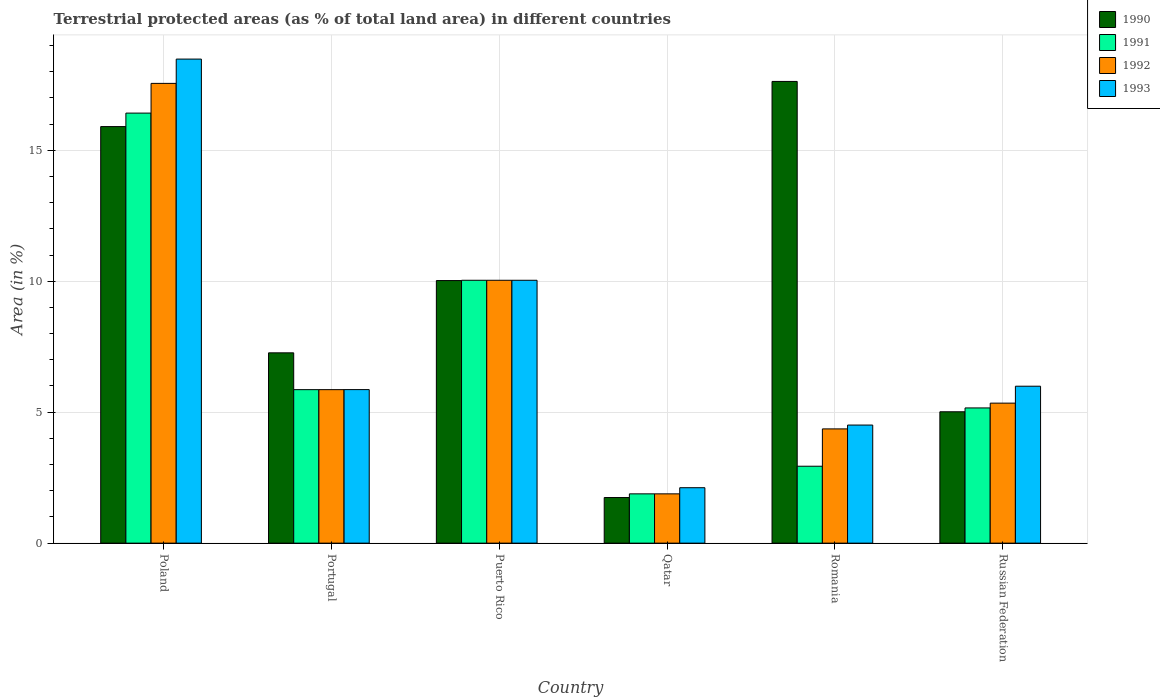How many bars are there on the 1st tick from the left?
Provide a succinct answer. 4. What is the label of the 3rd group of bars from the left?
Make the answer very short. Puerto Rico. In how many cases, is the number of bars for a given country not equal to the number of legend labels?
Offer a very short reply. 0. What is the percentage of terrestrial protected land in 1993 in Portugal?
Provide a short and direct response. 5.86. Across all countries, what is the maximum percentage of terrestrial protected land in 1993?
Your answer should be compact. 18.48. Across all countries, what is the minimum percentage of terrestrial protected land in 1991?
Your answer should be compact. 1.88. In which country was the percentage of terrestrial protected land in 1991 minimum?
Your answer should be very brief. Qatar. What is the total percentage of terrestrial protected land in 1992 in the graph?
Your response must be concise. 45.04. What is the difference between the percentage of terrestrial protected land in 1990 in Poland and that in Romania?
Your answer should be very brief. -1.72. What is the difference between the percentage of terrestrial protected land in 1991 in Portugal and the percentage of terrestrial protected land in 1992 in Russian Federation?
Offer a terse response. 0.52. What is the average percentage of terrestrial protected land in 1990 per country?
Your answer should be compact. 9.6. What is the ratio of the percentage of terrestrial protected land in 1993 in Qatar to that in Romania?
Offer a terse response. 0.47. What is the difference between the highest and the second highest percentage of terrestrial protected land in 1990?
Offer a very short reply. 7.6. What is the difference between the highest and the lowest percentage of terrestrial protected land in 1990?
Make the answer very short. 15.89. In how many countries, is the percentage of terrestrial protected land in 1991 greater than the average percentage of terrestrial protected land in 1991 taken over all countries?
Provide a short and direct response. 2. Is it the case that in every country, the sum of the percentage of terrestrial protected land in 1991 and percentage of terrestrial protected land in 1992 is greater than the sum of percentage of terrestrial protected land in 1990 and percentage of terrestrial protected land in 1993?
Provide a short and direct response. No. What does the 4th bar from the left in Puerto Rico represents?
Provide a succinct answer. 1993. Is it the case that in every country, the sum of the percentage of terrestrial protected land in 1993 and percentage of terrestrial protected land in 1991 is greater than the percentage of terrestrial protected land in 1992?
Give a very brief answer. Yes. Are all the bars in the graph horizontal?
Your response must be concise. No. How many countries are there in the graph?
Provide a short and direct response. 6. What is the difference between two consecutive major ticks on the Y-axis?
Offer a very short reply. 5. Where does the legend appear in the graph?
Give a very brief answer. Top right. What is the title of the graph?
Offer a very short reply. Terrestrial protected areas (as % of total land area) in different countries. What is the label or title of the Y-axis?
Your answer should be very brief. Area (in %). What is the Area (in %) of 1990 in Poland?
Keep it short and to the point. 15.9. What is the Area (in %) in 1991 in Poland?
Ensure brevity in your answer.  16.42. What is the Area (in %) in 1992 in Poland?
Your answer should be very brief. 17.55. What is the Area (in %) in 1993 in Poland?
Keep it short and to the point. 18.48. What is the Area (in %) of 1990 in Portugal?
Give a very brief answer. 7.27. What is the Area (in %) in 1991 in Portugal?
Offer a terse response. 5.86. What is the Area (in %) of 1992 in Portugal?
Ensure brevity in your answer.  5.86. What is the Area (in %) in 1993 in Portugal?
Provide a succinct answer. 5.86. What is the Area (in %) in 1990 in Puerto Rico?
Give a very brief answer. 10.03. What is the Area (in %) in 1991 in Puerto Rico?
Your answer should be compact. 10.04. What is the Area (in %) in 1992 in Puerto Rico?
Offer a terse response. 10.04. What is the Area (in %) of 1993 in Puerto Rico?
Provide a succinct answer. 10.04. What is the Area (in %) in 1990 in Qatar?
Provide a short and direct response. 1.74. What is the Area (in %) of 1991 in Qatar?
Provide a succinct answer. 1.88. What is the Area (in %) in 1992 in Qatar?
Ensure brevity in your answer.  1.88. What is the Area (in %) in 1993 in Qatar?
Your response must be concise. 2.12. What is the Area (in %) in 1990 in Romania?
Your response must be concise. 17.63. What is the Area (in %) of 1991 in Romania?
Offer a very short reply. 2.94. What is the Area (in %) of 1992 in Romania?
Give a very brief answer. 4.36. What is the Area (in %) of 1993 in Romania?
Ensure brevity in your answer.  4.51. What is the Area (in %) in 1990 in Russian Federation?
Offer a very short reply. 5.02. What is the Area (in %) of 1991 in Russian Federation?
Your answer should be very brief. 5.16. What is the Area (in %) of 1992 in Russian Federation?
Your answer should be very brief. 5.35. What is the Area (in %) of 1993 in Russian Federation?
Keep it short and to the point. 5.99. Across all countries, what is the maximum Area (in %) in 1990?
Your response must be concise. 17.63. Across all countries, what is the maximum Area (in %) of 1991?
Your answer should be compact. 16.42. Across all countries, what is the maximum Area (in %) in 1992?
Your answer should be very brief. 17.55. Across all countries, what is the maximum Area (in %) in 1993?
Offer a terse response. 18.48. Across all countries, what is the minimum Area (in %) of 1990?
Give a very brief answer. 1.74. Across all countries, what is the minimum Area (in %) in 1991?
Offer a very short reply. 1.88. Across all countries, what is the minimum Area (in %) of 1992?
Offer a very short reply. 1.88. Across all countries, what is the minimum Area (in %) in 1993?
Offer a terse response. 2.12. What is the total Area (in %) in 1990 in the graph?
Your answer should be very brief. 57.58. What is the total Area (in %) in 1991 in the graph?
Give a very brief answer. 42.3. What is the total Area (in %) of 1992 in the graph?
Your response must be concise. 45.04. What is the total Area (in %) in 1993 in the graph?
Offer a very short reply. 47. What is the difference between the Area (in %) in 1990 in Poland and that in Portugal?
Offer a very short reply. 8.64. What is the difference between the Area (in %) in 1991 in Poland and that in Portugal?
Your answer should be compact. 10.56. What is the difference between the Area (in %) in 1992 in Poland and that in Portugal?
Ensure brevity in your answer.  11.69. What is the difference between the Area (in %) of 1993 in Poland and that in Portugal?
Offer a very short reply. 12.62. What is the difference between the Area (in %) of 1990 in Poland and that in Puerto Rico?
Offer a terse response. 5.88. What is the difference between the Area (in %) of 1991 in Poland and that in Puerto Rico?
Provide a succinct answer. 6.38. What is the difference between the Area (in %) in 1992 in Poland and that in Puerto Rico?
Ensure brevity in your answer.  7.52. What is the difference between the Area (in %) in 1993 in Poland and that in Puerto Rico?
Your answer should be very brief. 8.45. What is the difference between the Area (in %) in 1990 in Poland and that in Qatar?
Offer a terse response. 14.16. What is the difference between the Area (in %) of 1991 in Poland and that in Qatar?
Ensure brevity in your answer.  14.54. What is the difference between the Area (in %) of 1992 in Poland and that in Qatar?
Provide a succinct answer. 15.67. What is the difference between the Area (in %) of 1993 in Poland and that in Qatar?
Your answer should be very brief. 16.37. What is the difference between the Area (in %) of 1990 in Poland and that in Romania?
Your response must be concise. -1.72. What is the difference between the Area (in %) of 1991 in Poland and that in Romania?
Provide a succinct answer. 13.48. What is the difference between the Area (in %) in 1992 in Poland and that in Romania?
Offer a terse response. 13.19. What is the difference between the Area (in %) of 1993 in Poland and that in Romania?
Keep it short and to the point. 13.97. What is the difference between the Area (in %) of 1990 in Poland and that in Russian Federation?
Provide a short and direct response. 10.89. What is the difference between the Area (in %) in 1991 in Poland and that in Russian Federation?
Offer a very short reply. 11.26. What is the difference between the Area (in %) in 1992 in Poland and that in Russian Federation?
Provide a succinct answer. 12.21. What is the difference between the Area (in %) of 1993 in Poland and that in Russian Federation?
Provide a succinct answer. 12.49. What is the difference between the Area (in %) in 1990 in Portugal and that in Puerto Rico?
Keep it short and to the point. -2.76. What is the difference between the Area (in %) in 1991 in Portugal and that in Puerto Rico?
Offer a terse response. -4.18. What is the difference between the Area (in %) in 1992 in Portugal and that in Puerto Rico?
Make the answer very short. -4.18. What is the difference between the Area (in %) in 1993 in Portugal and that in Puerto Rico?
Your answer should be compact. -4.17. What is the difference between the Area (in %) in 1990 in Portugal and that in Qatar?
Offer a very short reply. 5.53. What is the difference between the Area (in %) in 1991 in Portugal and that in Qatar?
Give a very brief answer. 3.98. What is the difference between the Area (in %) in 1992 in Portugal and that in Qatar?
Your answer should be compact. 3.98. What is the difference between the Area (in %) in 1993 in Portugal and that in Qatar?
Provide a succinct answer. 3.75. What is the difference between the Area (in %) of 1990 in Portugal and that in Romania?
Offer a terse response. -10.36. What is the difference between the Area (in %) of 1991 in Portugal and that in Romania?
Make the answer very short. 2.92. What is the difference between the Area (in %) of 1992 in Portugal and that in Romania?
Provide a short and direct response. 1.5. What is the difference between the Area (in %) of 1993 in Portugal and that in Romania?
Keep it short and to the point. 1.35. What is the difference between the Area (in %) in 1990 in Portugal and that in Russian Federation?
Provide a succinct answer. 2.25. What is the difference between the Area (in %) in 1991 in Portugal and that in Russian Federation?
Offer a very short reply. 0.7. What is the difference between the Area (in %) of 1992 in Portugal and that in Russian Federation?
Your answer should be very brief. 0.52. What is the difference between the Area (in %) in 1993 in Portugal and that in Russian Federation?
Offer a terse response. -0.13. What is the difference between the Area (in %) of 1990 in Puerto Rico and that in Qatar?
Your response must be concise. 8.28. What is the difference between the Area (in %) in 1991 in Puerto Rico and that in Qatar?
Your response must be concise. 8.15. What is the difference between the Area (in %) in 1992 in Puerto Rico and that in Qatar?
Give a very brief answer. 8.15. What is the difference between the Area (in %) in 1993 in Puerto Rico and that in Qatar?
Your answer should be very brief. 7.92. What is the difference between the Area (in %) of 1990 in Puerto Rico and that in Romania?
Provide a succinct answer. -7.6. What is the difference between the Area (in %) in 1991 in Puerto Rico and that in Romania?
Keep it short and to the point. 7.1. What is the difference between the Area (in %) of 1992 in Puerto Rico and that in Romania?
Provide a short and direct response. 5.67. What is the difference between the Area (in %) of 1993 in Puerto Rico and that in Romania?
Your response must be concise. 5.53. What is the difference between the Area (in %) of 1990 in Puerto Rico and that in Russian Federation?
Your response must be concise. 5.01. What is the difference between the Area (in %) in 1991 in Puerto Rico and that in Russian Federation?
Keep it short and to the point. 4.87. What is the difference between the Area (in %) in 1992 in Puerto Rico and that in Russian Federation?
Your answer should be compact. 4.69. What is the difference between the Area (in %) in 1993 in Puerto Rico and that in Russian Federation?
Offer a very short reply. 4.04. What is the difference between the Area (in %) in 1990 in Qatar and that in Romania?
Provide a succinct answer. -15.89. What is the difference between the Area (in %) of 1991 in Qatar and that in Romania?
Keep it short and to the point. -1.05. What is the difference between the Area (in %) of 1992 in Qatar and that in Romania?
Give a very brief answer. -2.48. What is the difference between the Area (in %) in 1993 in Qatar and that in Romania?
Provide a short and direct response. -2.39. What is the difference between the Area (in %) in 1990 in Qatar and that in Russian Federation?
Your answer should be very brief. -3.27. What is the difference between the Area (in %) in 1991 in Qatar and that in Russian Federation?
Your answer should be compact. -3.28. What is the difference between the Area (in %) of 1992 in Qatar and that in Russian Federation?
Keep it short and to the point. -3.46. What is the difference between the Area (in %) in 1993 in Qatar and that in Russian Federation?
Ensure brevity in your answer.  -3.88. What is the difference between the Area (in %) in 1990 in Romania and that in Russian Federation?
Give a very brief answer. 12.61. What is the difference between the Area (in %) of 1991 in Romania and that in Russian Federation?
Ensure brevity in your answer.  -2.23. What is the difference between the Area (in %) of 1992 in Romania and that in Russian Federation?
Your answer should be compact. -0.98. What is the difference between the Area (in %) in 1993 in Romania and that in Russian Federation?
Your answer should be compact. -1.48. What is the difference between the Area (in %) in 1990 in Poland and the Area (in %) in 1991 in Portugal?
Provide a short and direct response. 10.04. What is the difference between the Area (in %) in 1990 in Poland and the Area (in %) in 1992 in Portugal?
Provide a succinct answer. 10.04. What is the difference between the Area (in %) of 1990 in Poland and the Area (in %) of 1993 in Portugal?
Your answer should be compact. 10.04. What is the difference between the Area (in %) in 1991 in Poland and the Area (in %) in 1992 in Portugal?
Provide a succinct answer. 10.56. What is the difference between the Area (in %) of 1991 in Poland and the Area (in %) of 1993 in Portugal?
Your answer should be very brief. 10.56. What is the difference between the Area (in %) in 1992 in Poland and the Area (in %) in 1993 in Portugal?
Offer a terse response. 11.69. What is the difference between the Area (in %) in 1990 in Poland and the Area (in %) in 1991 in Puerto Rico?
Keep it short and to the point. 5.87. What is the difference between the Area (in %) of 1990 in Poland and the Area (in %) of 1992 in Puerto Rico?
Offer a very short reply. 5.87. What is the difference between the Area (in %) in 1990 in Poland and the Area (in %) in 1993 in Puerto Rico?
Your answer should be very brief. 5.87. What is the difference between the Area (in %) of 1991 in Poland and the Area (in %) of 1992 in Puerto Rico?
Provide a short and direct response. 6.38. What is the difference between the Area (in %) of 1991 in Poland and the Area (in %) of 1993 in Puerto Rico?
Offer a very short reply. 6.38. What is the difference between the Area (in %) in 1992 in Poland and the Area (in %) in 1993 in Puerto Rico?
Ensure brevity in your answer.  7.52. What is the difference between the Area (in %) of 1990 in Poland and the Area (in %) of 1991 in Qatar?
Provide a succinct answer. 14.02. What is the difference between the Area (in %) in 1990 in Poland and the Area (in %) in 1992 in Qatar?
Your answer should be very brief. 14.02. What is the difference between the Area (in %) in 1990 in Poland and the Area (in %) in 1993 in Qatar?
Give a very brief answer. 13.79. What is the difference between the Area (in %) in 1991 in Poland and the Area (in %) in 1992 in Qatar?
Offer a terse response. 14.54. What is the difference between the Area (in %) of 1991 in Poland and the Area (in %) of 1993 in Qatar?
Provide a short and direct response. 14.3. What is the difference between the Area (in %) in 1992 in Poland and the Area (in %) in 1993 in Qatar?
Your response must be concise. 15.44. What is the difference between the Area (in %) in 1990 in Poland and the Area (in %) in 1991 in Romania?
Your answer should be very brief. 12.97. What is the difference between the Area (in %) of 1990 in Poland and the Area (in %) of 1992 in Romania?
Make the answer very short. 11.54. What is the difference between the Area (in %) of 1990 in Poland and the Area (in %) of 1993 in Romania?
Provide a short and direct response. 11.4. What is the difference between the Area (in %) of 1991 in Poland and the Area (in %) of 1992 in Romania?
Your answer should be compact. 12.06. What is the difference between the Area (in %) of 1991 in Poland and the Area (in %) of 1993 in Romania?
Your response must be concise. 11.91. What is the difference between the Area (in %) of 1992 in Poland and the Area (in %) of 1993 in Romania?
Make the answer very short. 13.04. What is the difference between the Area (in %) in 1990 in Poland and the Area (in %) in 1991 in Russian Federation?
Offer a terse response. 10.74. What is the difference between the Area (in %) in 1990 in Poland and the Area (in %) in 1992 in Russian Federation?
Your response must be concise. 10.56. What is the difference between the Area (in %) of 1990 in Poland and the Area (in %) of 1993 in Russian Federation?
Offer a very short reply. 9.91. What is the difference between the Area (in %) in 1991 in Poland and the Area (in %) in 1992 in Russian Federation?
Your response must be concise. 11.07. What is the difference between the Area (in %) in 1991 in Poland and the Area (in %) in 1993 in Russian Federation?
Provide a succinct answer. 10.43. What is the difference between the Area (in %) in 1992 in Poland and the Area (in %) in 1993 in Russian Federation?
Ensure brevity in your answer.  11.56. What is the difference between the Area (in %) of 1990 in Portugal and the Area (in %) of 1991 in Puerto Rico?
Keep it short and to the point. -2.77. What is the difference between the Area (in %) in 1990 in Portugal and the Area (in %) in 1992 in Puerto Rico?
Give a very brief answer. -2.77. What is the difference between the Area (in %) in 1990 in Portugal and the Area (in %) in 1993 in Puerto Rico?
Give a very brief answer. -2.77. What is the difference between the Area (in %) in 1991 in Portugal and the Area (in %) in 1992 in Puerto Rico?
Your response must be concise. -4.18. What is the difference between the Area (in %) in 1991 in Portugal and the Area (in %) in 1993 in Puerto Rico?
Your answer should be very brief. -4.18. What is the difference between the Area (in %) of 1992 in Portugal and the Area (in %) of 1993 in Puerto Rico?
Your answer should be compact. -4.18. What is the difference between the Area (in %) of 1990 in Portugal and the Area (in %) of 1991 in Qatar?
Provide a succinct answer. 5.38. What is the difference between the Area (in %) in 1990 in Portugal and the Area (in %) in 1992 in Qatar?
Give a very brief answer. 5.38. What is the difference between the Area (in %) of 1990 in Portugal and the Area (in %) of 1993 in Qatar?
Provide a succinct answer. 5.15. What is the difference between the Area (in %) in 1991 in Portugal and the Area (in %) in 1992 in Qatar?
Provide a succinct answer. 3.98. What is the difference between the Area (in %) of 1991 in Portugal and the Area (in %) of 1993 in Qatar?
Provide a succinct answer. 3.74. What is the difference between the Area (in %) in 1992 in Portugal and the Area (in %) in 1993 in Qatar?
Give a very brief answer. 3.74. What is the difference between the Area (in %) of 1990 in Portugal and the Area (in %) of 1991 in Romania?
Make the answer very short. 4.33. What is the difference between the Area (in %) in 1990 in Portugal and the Area (in %) in 1992 in Romania?
Provide a succinct answer. 2.9. What is the difference between the Area (in %) in 1990 in Portugal and the Area (in %) in 1993 in Romania?
Your answer should be compact. 2.76. What is the difference between the Area (in %) of 1991 in Portugal and the Area (in %) of 1992 in Romania?
Your response must be concise. 1.5. What is the difference between the Area (in %) of 1991 in Portugal and the Area (in %) of 1993 in Romania?
Provide a short and direct response. 1.35. What is the difference between the Area (in %) in 1992 in Portugal and the Area (in %) in 1993 in Romania?
Provide a short and direct response. 1.35. What is the difference between the Area (in %) of 1990 in Portugal and the Area (in %) of 1991 in Russian Federation?
Your answer should be compact. 2.1. What is the difference between the Area (in %) in 1990 in Portugal and the Area (in %) in 1992 in Russian Federation?
Keep it short and to the point. 1.92. What is the difference between the Area (in %) in 1990 in Portugal and the Area (in %) in 1993 in Russian Federation?
Your answer should be compact. 1.27. What is the difference between the Area (in %) of 1991 in Portugal and the Area (in %) of 1992 in Russian Federation?
Offer a terse response. 0.52. What is the difference between the Area (in %) of 1991 in Portugal and the Area (in %) of 1993 in Russian Federation?
Your answer should be very brief. -0.13. What is the difference between the Area (in %) in 1992 in Portugal and the Area (in %) in 1993 in Russian Federation?
Give a very brief answer. -0.13. What is the difference between the Area (in %) in 1990 in Puerto Rico and the Area (in %) in 1991 in Qatar?
Provide a short and direct response. 8.14. What is the difference between the Area (in %) of 1990 in Puerto Rico and the Area (in %) of 1992 in Qatar?
Your answer should be compact. 8.14. What is the difference between the Area (in %) in 1990 in Puerto Rico and the Area (in %) in 1993 in Qatar?
Keep it short and to the point. 7.91. What is the difference between the Area (in %) of 1991 in Puerto Rico and the Area (in %) of 1992 in Qatar?
Keep it short and to the point. 8.15. What is the difference between the Area (in %) of 1991 in Puerto Rico and the Area (in %) of 1993 in Qatar?
Give a very brief answer. 7.92. What is the difference between the Area (in %) of 1992 in Puerto Rico and the Area (in %) of 1993 in Qatar?
Keep it short and to the point. 7.92. What is the difference between the Area (in %) of 1990 in Puerto Rico and the Area (in %) of 1991 in Romania?
Your response must be concise. 7.09. What is the difference between the Area (in %) of 1990 in Puerto Rico and the Area (in %) of 1992 in Romania?
Your response must be concise. 5.66. What is the difference between the Area (in %) of 1990 in Puerto Rico and the Area (in %) of 1993 in Romania?
Provide a succinct answer. 5.52. What is the difference between the Area (in %) of 1991 in Puerto Rico and the Area (in %) of 1992 in Romania?
Offer a terse response. 5.67. What is the difference between the Area (in %) in 1991 in Puerto Rico and the Area (in %) in 1993 in Romania?
Give a very brief answer. 5.53. What is the difference between the Area (in %) in 1992 in Puerto Rico and the Area (in %) in 1993 in Romania?
Your response must be concise. 5.53. What is the difference between the Area (in %) in 1990 in Puerto Rico and the Area (in %) in 1991 in Russian Federation?
Give a very brief answer. 4.86. What is the difference between the Area (in %) of 1990 in Puerto Rico and the Area (in %) of 1992 in Russian Federation?
Provide a short and direct response. 4.68. What is the difference between the Area (in %) in 1990 in Puerto Rico and the Area (in %) in 1993 in Russian Federation?
Your response must be concise. 4.03. What is the difference between the Area (in %) of 1991 in Puerto Rico and the Area (in %) of 1992 in Russian Federation?
Make the answer very short. 4.69. What is the difference between the Area (in %) of 1991 in Puerto Rico and the Area (in %) of 1993 in Russian Federation?
Offer a very short reply. 4.04. What is the difference between the Area (in %) of 1992 in Puerto Rico and the Area (in %) of 1993 in Russian Federation?
Your answer should be compact. 4.04. What is the difference between the Area (in %) of 1990 in Qatar and the Area (in %) of 1991 in Romania?
Provide a succinct answer. -1.2. What is the difference between the Area (in %) of 1990 in Qatar and the Area (in %) of 1992 in Romania?
Ensure brevity in your answer.  -2.62. What is the difference between the Area (in %) of 1990 in Qatar and the Area (in %) of 1993 in Romania?
Give a very brief answer. -2.77. What is the difference between the Area (in %) of 1991 in Qatar and the Area (in %) of 1992 in Romania?
Provide a short and direct response. -2.48. What is the difference between the Area (in %) of 1991 in Qatar and the Area (in %) of 1993 in Romania?
Keep it short and to the point. -2.63. What is the difference between the Area (in %) of 1992 in Qatar and the Area (in %) of 1993 in Romania?
Make the answer very short. -2.63. What is the difference between the Area (in %) in 1990 in Qatar and the Area (in %) in 1991 in Russian Federation?
Your answer should be compact. -3.42. What is the difference between the Area (in %) of 1990 in Qatar and the Area (in %) of 1992 in Russian Federation?
Your response must be concise. -3.6. What is the difference between the Area (in %) of 1990 in Qatar and the Area (in %) of 1993 in Russian Federation?
Provide a short and direct response. -4.25. What is the difference between the Area (in %) in 1991 in Qatar and the Area (in %) in 1992 in Russian Federation?
Your answer should be compact. -3.46. What is the difference between the Area (in %) in 1991 in Qatar and the Area (in %) in 1993 in Russian Federation?
Your response must be concise. -4.11. What is the difference between the Area (in %) of 1992 in Qatar and the Area (in %) of 1993 in Russian Federation?
Your response must be concise. -4.11. What is the difference between the Area (in %) in 1990 in Romania and the Area (in %) in 1991 in Russian Federation?
Make the answer very short. 12.47. What is the difference between the Area (in %) of 1990 in Romania and the Area (in %) of 1992 in Russian Federation?
Your answer should be compact. 12.28. What is the difference between the Area (in %) in 1990 in Romania and the Area (in %) in 1993 in Russian Federation?
Give a very brief answer. 11.64. What is the difference between the Area (in %) in 1991 in Romania and the Area (in %) in 1992 in Russian Federation?
Your answer should be compact. -2.41. What is the difference between the Area (in %) of 1991 in Romania and the Area (in %) of 1993 in Russian Federation?
Offer a terse response. -3.06. What is the difference between the Area (in %) of 1992 in Romania and the Area (in %) of 1993 in Russian Federation?
Keep it short and to the point. -1.63. What is the average Area (in %) of 1990 per country?
Provide a succinct answer. 9.6. What is the average Area (in %) in 1991 per country?
Your answer should be compact. 7.05. What is the average Area (in %) in 1992 per country?
Your answer should be compact. 7.51. What is the average Area (in %) of 1993 per country?
Your answer should be very brief. 7.83. What is the difference between the Area (in %) in 1990 and Area (in %) in 1991 in Poland?
Provide a succinct answer. -0.51. What is the difference between the Area (in %) in 1990 and Area (in %) in 1992 in Poland?
Your answer should be very brief. -1.65. What is the difference between the Area (in %) in 1990 and Area (in %) in 1993 in Poland?
Your answer should be compact. -2.58. What is the difference between the Area (in %) in 1991 and Area (in %) in 1992 in Poland?
Offer a very short reply. -1.13. What is the difference between the Area (in %) in 1991 and Area (in %) in 1993 in Poland?
Ensure brevity in your answer.  -2.06. What is the difference between the Area (in %) of 1992 and Area (in %) of 1993 in Poland?
Give a very brief answer. -0.93. What is the difference between the Area (in %) of 1990 and Area (in %) of 1991 in Portugal?
Offer a terse response. 1.41. What is the difference between the Area (in %) of 1990 and Area (in %) of 1992 in Portugal?
Ensure brevity in your answer.  1.41. What is the difference between the Area (in %) in 1990 and Area (in %) in 1993 in Portugal?
Keep it short and to the point. 1.4. What is the difference between the Area (in %) in 1991 and Area (in %) in 1992 in Portugal?
Your response must be concise. 0. What is the difference between the Area (in %) in 1991 and Area (in %) in 1993 in Portugal?
Make the answer very short. -0. What is the difference between the Area (in %) of 1992 and Area (in %) of 1993 in Portugal?
Your response must be concise. -0. What is the difference between the Area (in %) in 1990 and Area (in %) in 1991 in Puerto Rico?
Provide a succinct answer. -0.01. What is the difference between the Area (in %) in 1990 and Area (in %) in 1992 in Puerto Rico?
Give a very brief answer. -0.01. What is the difference between the Area (in %) in 1990 and Area (in %) in 1993 in Puerto Rico?
Provide a short and direct response. -0.01. What is the difference between the Area (in %) of 1991 and Area (in %) of 1993 in Puerto Rico?
Provide a succinct answer. 0. What is the difference between the Area (in %) of 1990 and Area (in %) of 1991 in Qatar?
Provide a succinct answer. -0.14. What is the difference between the Area (in %) in 1990 and Area (in %) in 1992 in Qatar?
Your answer should be very brief. -0.14. What is the difference between the Area (in %) in 1990 and Area (in %) in 1993 in Qatar?
Provide a short and direct response. -0.38. What is the difference between the Area (in %) of 1991 and Area (in %) of 1993 in Qatar?
Provide a short and direct response. -0.23. What is the difference between the Area (in %) in 1992 and Area (in %) in 1993 in Qatar?
Keep it short and to the point. -0.23. What is the difference between the Area (in %) of 1990 and Area (in %) of 1991 in Romania?
Provide a succinct answer. 14.69. What is the difference between the Area (in %) of 1990 and Area (in %) of 1992 in Romania?
Give a very brief answer. 13.27. What is the difference between the Area (in %) of 1990 and Area (in %) of 1993 in Romania?
Ensure brevity in your answer.  13.12. What is the difference between the Area (in %) of 1991 and Area (in %) of 1992 in Romania?
Make the answer very short. -1.43. What is the difference between the Area (in %) in 1991 and Area (in %) in 1993 in Romania?
Provide a succinct answer. -1.57. What is the difference between the Area (in %) in 1992 and Area (in %) in 1993 in Romania?
Your answer should be very brief. -0.15. What is the difference between the Area (in %) of 1990 and Area (in %) of 1991 in Russian Federation?
Your answer should be compact. -0.15. What is the difference between the Area (in %) in 1990 and Area (in %) in 1992 in Russian Federation?
Your response must be concise. -0.33. What is the difference between the Area (in %) in 1990 and Area (in %) in 1993 in Russian Federation?
Provide a short and direct response. -0.98. What is the difference between the Area (in %) in 1991 and Area (in %) in 1992 in Russian Federation?
Keep it short and to the point. -0.18. What is the difference between the Area (in %) in 1991 and Area (in %) in 1993 in Russian Federation?
Your answer should be very brief. -0.83. What is the difference between the Area (in %) of 1992 and Area (in %) of 1993 in Russian Federation?
Your response must be concise. -0.65. What is the ratio of the Area (in %) in 1990 in Poland to that in Portugal?
Keep it short and to the point. 2.19. What is the ratio of the Area (in %) in 1991 in Poland to that in Portugal?
Your answer should be compact. 2.8. What is the ratio of the Area (in %) of 1992 in Poland to that in Portugal?
Your answer should be very brief. 3. What is the ratio of the Area (in %) in 1993 in Poland to that in Portugal?
Ensure brevity in your answer.  3.15. What is the ratio of the Area (in %) in 1990 in Poland to that in Puerto Rico?
Make the answer very short. 1.59. What is the ratio of the Area (in %) in 1991 in Poland to that in Puerto Rico?
Provide a succinct answer. 1.64. What is the ratio of the Area (in %) in 1992 in Poland to that in Puerto Rico?
Provide a succinct answer. 1.75. What is the ratio of the Area (in %) of 1993 in Poland to that in Puerto Rico?
Keep it short and to the point. 1.84. What is the ratio of the Area (in %) in 1990 in Poland to that in Qatar?
Your response must be concise. 9.13. What is the ratio of the Area (in %) in 1991 in Poland to that in Qatar?
Ensure brevity in your answer.  8.72. What is the ratio of the Area (in %) of 1992 in Poland to that in Qatar?
Offer a very short reply. 9.33. What is the ratio of the Area (in %) of 1993 in Poland to that in Qatar?
Offer a very short reply. 8.73. What is the ratio of the Area (in %) of 1990 in Poland to that in Romania?
Your response must be concise. 0.9. What is the ratio of the Area (in %) of 1991 in Poland to that in Romania?
Your answer should be compact. 5.59. What is the ratio of the Area (in %) of 1992 in Poland to that in Romania?
Provide a short and direct response. 4.02. What is the ratio of the Area (in %) in 1993 in Poland to that in Romania?
Provide a succinct answer. 4.1. What is the ratio of the Area (in %) of 1990 in Poland to that in Russian Federation?
Make the answer very short. 3.17. What is the ratio of the Area (in %) of 1991 in Poland to that in Russian Federation?
Give a very brief answer. 3.18. What is the ratio of the Area (in %) of 1992 in Poland to that in Russian Federation?
Ensure brevity in your answer.  3.28. What is the ratio of the Area (in %) in 1993 in Poland to that in Russian Federation?
Make the answer very short. 3.08. What is the ratio of the Area (in %) of 1990 in Portugal to that in Puerto Rico?
Your response must be concise. 0.72. What is the ratio of the Area (in %) of 1991 in Portugal to that in Puerto Rico?
Keep it short and to the point. 0.58. What is the ratio of the Area (in %) of 1992 in Portugal to that in Puerto Rico?
Make the answer very short. 0.58. What is the ratio of the Area (in %) of 1993 in Portugal to that in Puerto Rico?
Offer a terse response. 0.58. What is the ratio of the Area (in %) in 1990 in Portugal to that in Qatar?
Provide a short and direct response. 4.17. What is the ratio of the Area (in %) of 1991 in Portugal to that in Qatar?
Give a very brief answer. 3.11. What is the ratio of the Area (in %) in 1992 in Portugal to that in Qatar?
Provide a short and direct response. 3.11. What is the ratio of the Area (in %) in 1993 in Portugal to that in Qatar?
Your response must be concise. 2.77. What is the ratio of the Area (in %) of 1990 in Portugal to that in Romania?
Give a very brief answer. 0.41. What is the ratio of the Area (in %) of 1991 in Portugal to that in Romania?
Ensure brevity in your answer.  2. What is the ratio of the Area (in %) of 1992 in Portugal to that in Romania?
Provide a succinct answer. 1.34. What is the ratio of the Area (in %) in 1993 in Portugal to that in Romania?
Offer a terse response. 1.3. What is the ratio of the Area (in %) of 1990 in Portugal to that in Russian Federation?
Ensure brevity in your answer.  1.45. What is the ratio of the Area (in %) of 1991 in Portugal to that in Russian Federation?
Ensure brevity in your answer.  1.14. What is the ratio of the Area (in %) in 1992 in Portugal to that in Russian Federation?
Keep it short and to the point. 1.1. What is the ratio of the Area (in %) in 1993 in Portugal to that in Russian Federation?
Make the answer very short. 0.98. What is the ratio of the Area (in %) of 1990 in Puerto Rico to that in Qatar?
Give a very brief answer. 5.76. What is the ratio of the Area (in %) in 1991 in Puerto Rico to that in Qatar?
Provide a succinct answer. 5.33. What is the ratio of the Area (in %) in 1992 in Puerto Rico to that in Qatar?
Provide a succinct answer. 5.33. What is the ratio of the Area (in %) of 1993 in Puerto Rico to that in Qatar?
Your response must be concise. 4.74. What is the ratio of the Area (in %) in 1990 in Puerto Rico to that in Romania?
Provide a short and direct response. 0.57. What is the ratio of the Area (in %) of 1991 in Puerto Rico to that in Romania?
Offer a very short reply. 3.42. What is the ratio of the Area (in %) of 1992 in Puerto Rico to that in Romania?
Provide a succinct answer. 2.3. What is the ratio of the Area (in %) of 1993 in Puerto Rico to that in Romania?
Keep it short and to the point. 2.23. What is the ratio of the Area (in %) in 1990 in Puerto Rico to that in Russian Federation?
Your response must be concise. 2. What is the ratio of the Area (in %) in 1991 in Puerto Rico to that in Russian Federation?
Provide a succinct answer. 1.94. What is the ratio of the Area (in %) of 1992 in Puerto Rico to that in Russian Federation?
Ensure brevity in your answer.  1.88. What is the ratio of the Area (in %) in 1993 in Puerto Rico to that in Russian Federation?
Offer a terse response. 1.68. What is the ratio of the Area (in %) of 1990 in Qatar to that in Romania?
Provide a succinct answer. 0.1. What is the ratio of the Area (in %) in 1991 in Qatar to that in Romania?
Offer a terse response. 0.64. What is the ratio of the Area (in %) of 1992 in Qatar to that in Romania?
Ensure brevity in your answer.  0.43. What is the ratio of the Area (in %) of 1993 in Qatar to that in Romania?
Keep it short and to the point. 0.47. What is the ratio of the Area (in %) of 1990 in Qatar to that in Russian Federation?
Your answer should be very brief. 0.35. What is the ratio of the Area (in %) in 1991 in Qatar to that in Russian Federation?
Offer a very short reply. 0.36. What is the ratio of the Area (in %) in 1992 in Qatar to that in Russian Federation?
Ensure brevity in your answer.  0.35. What is the ratio of the Area (in %) of 1993 in Qatar to that in Russian Federation?
Your answer should be compact. 0.35. What is the ratio of the Area (in %) in 1990 in Romania to that in Russian Federation?
Offer a very short reply. 3.51. What is the ratio of the Area (in %) of 1991 in Romania to that in Russian Federation?
Keep it short and to the point. 0.57. What is the ratio of the Area (in %) of 1992 in Romania to that in Russian Federation?
Provide a short and direct response. 0.82. What is the ratio of the Area (in %) in 1993 in Romania to that in Russian Federation?
Your answer should be very brief. 0.75. What is the difference between the highest and the second highest Area (in %) in 1990?
Your answer should be very brief. 1.72. What is the difference between the highest and the second highest Area (in %) of 1991?
Offer a terse response. 6.38. What is the difference between the highest and the second highest Area (in %) in 1992?
Your answer should be very brief. 7.52. What is the difference between the highest and the second highest Area (in %) in 1993?
Keep it short and to the point. 8.45. What is the difference between the highest and the lowest Area (in %) in 1990?
Offer a terse response. 15.89. What is the difference between the highest and the lowest Area (in %) in 1991?
Keep it short and to the point. 14.54. What is the difference between the highest and the lowest Area (in %) in 1992?
Offer a terse response. 15.67. What is the difference between the highest and the lowest Area (in %) of 1993?
Your answer should be compact. 16.37. 